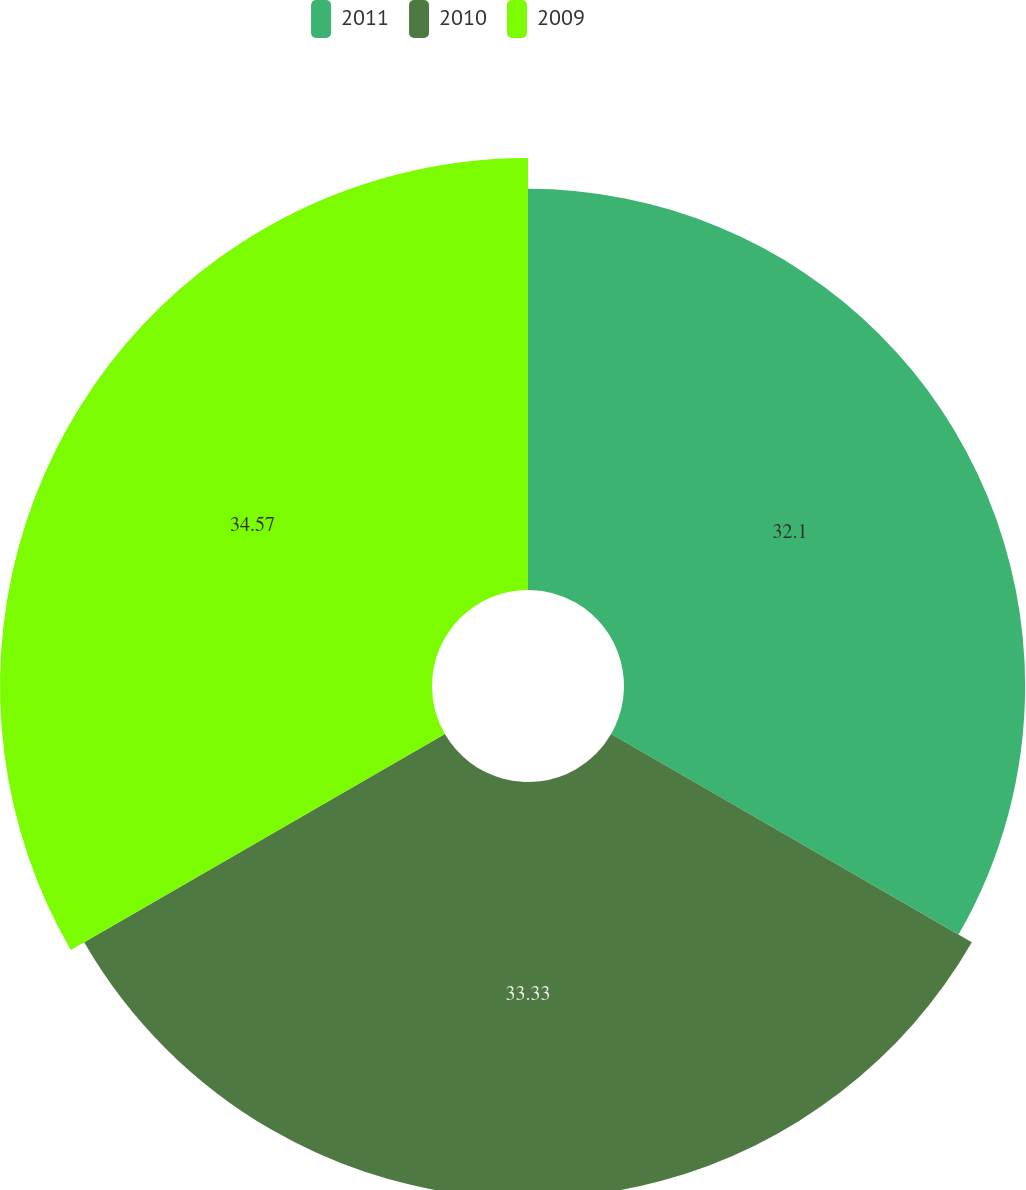Convert chart to OTSL. <chart><loc_0><loc_0><loc_500><loc_500><pie_chart><fcel>2011<fcel>2010<fcel>2009<nl><fcel>32.1%<fcel>33.33%<fcel>34.57%<nl></chart> 